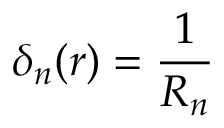Convert formula to latex. <formula><loc_0><loc_0><loc_500><loc_500>\delta _ { n } ( r ) = { \frac { 1 } { R _ { n } } }</formula> 